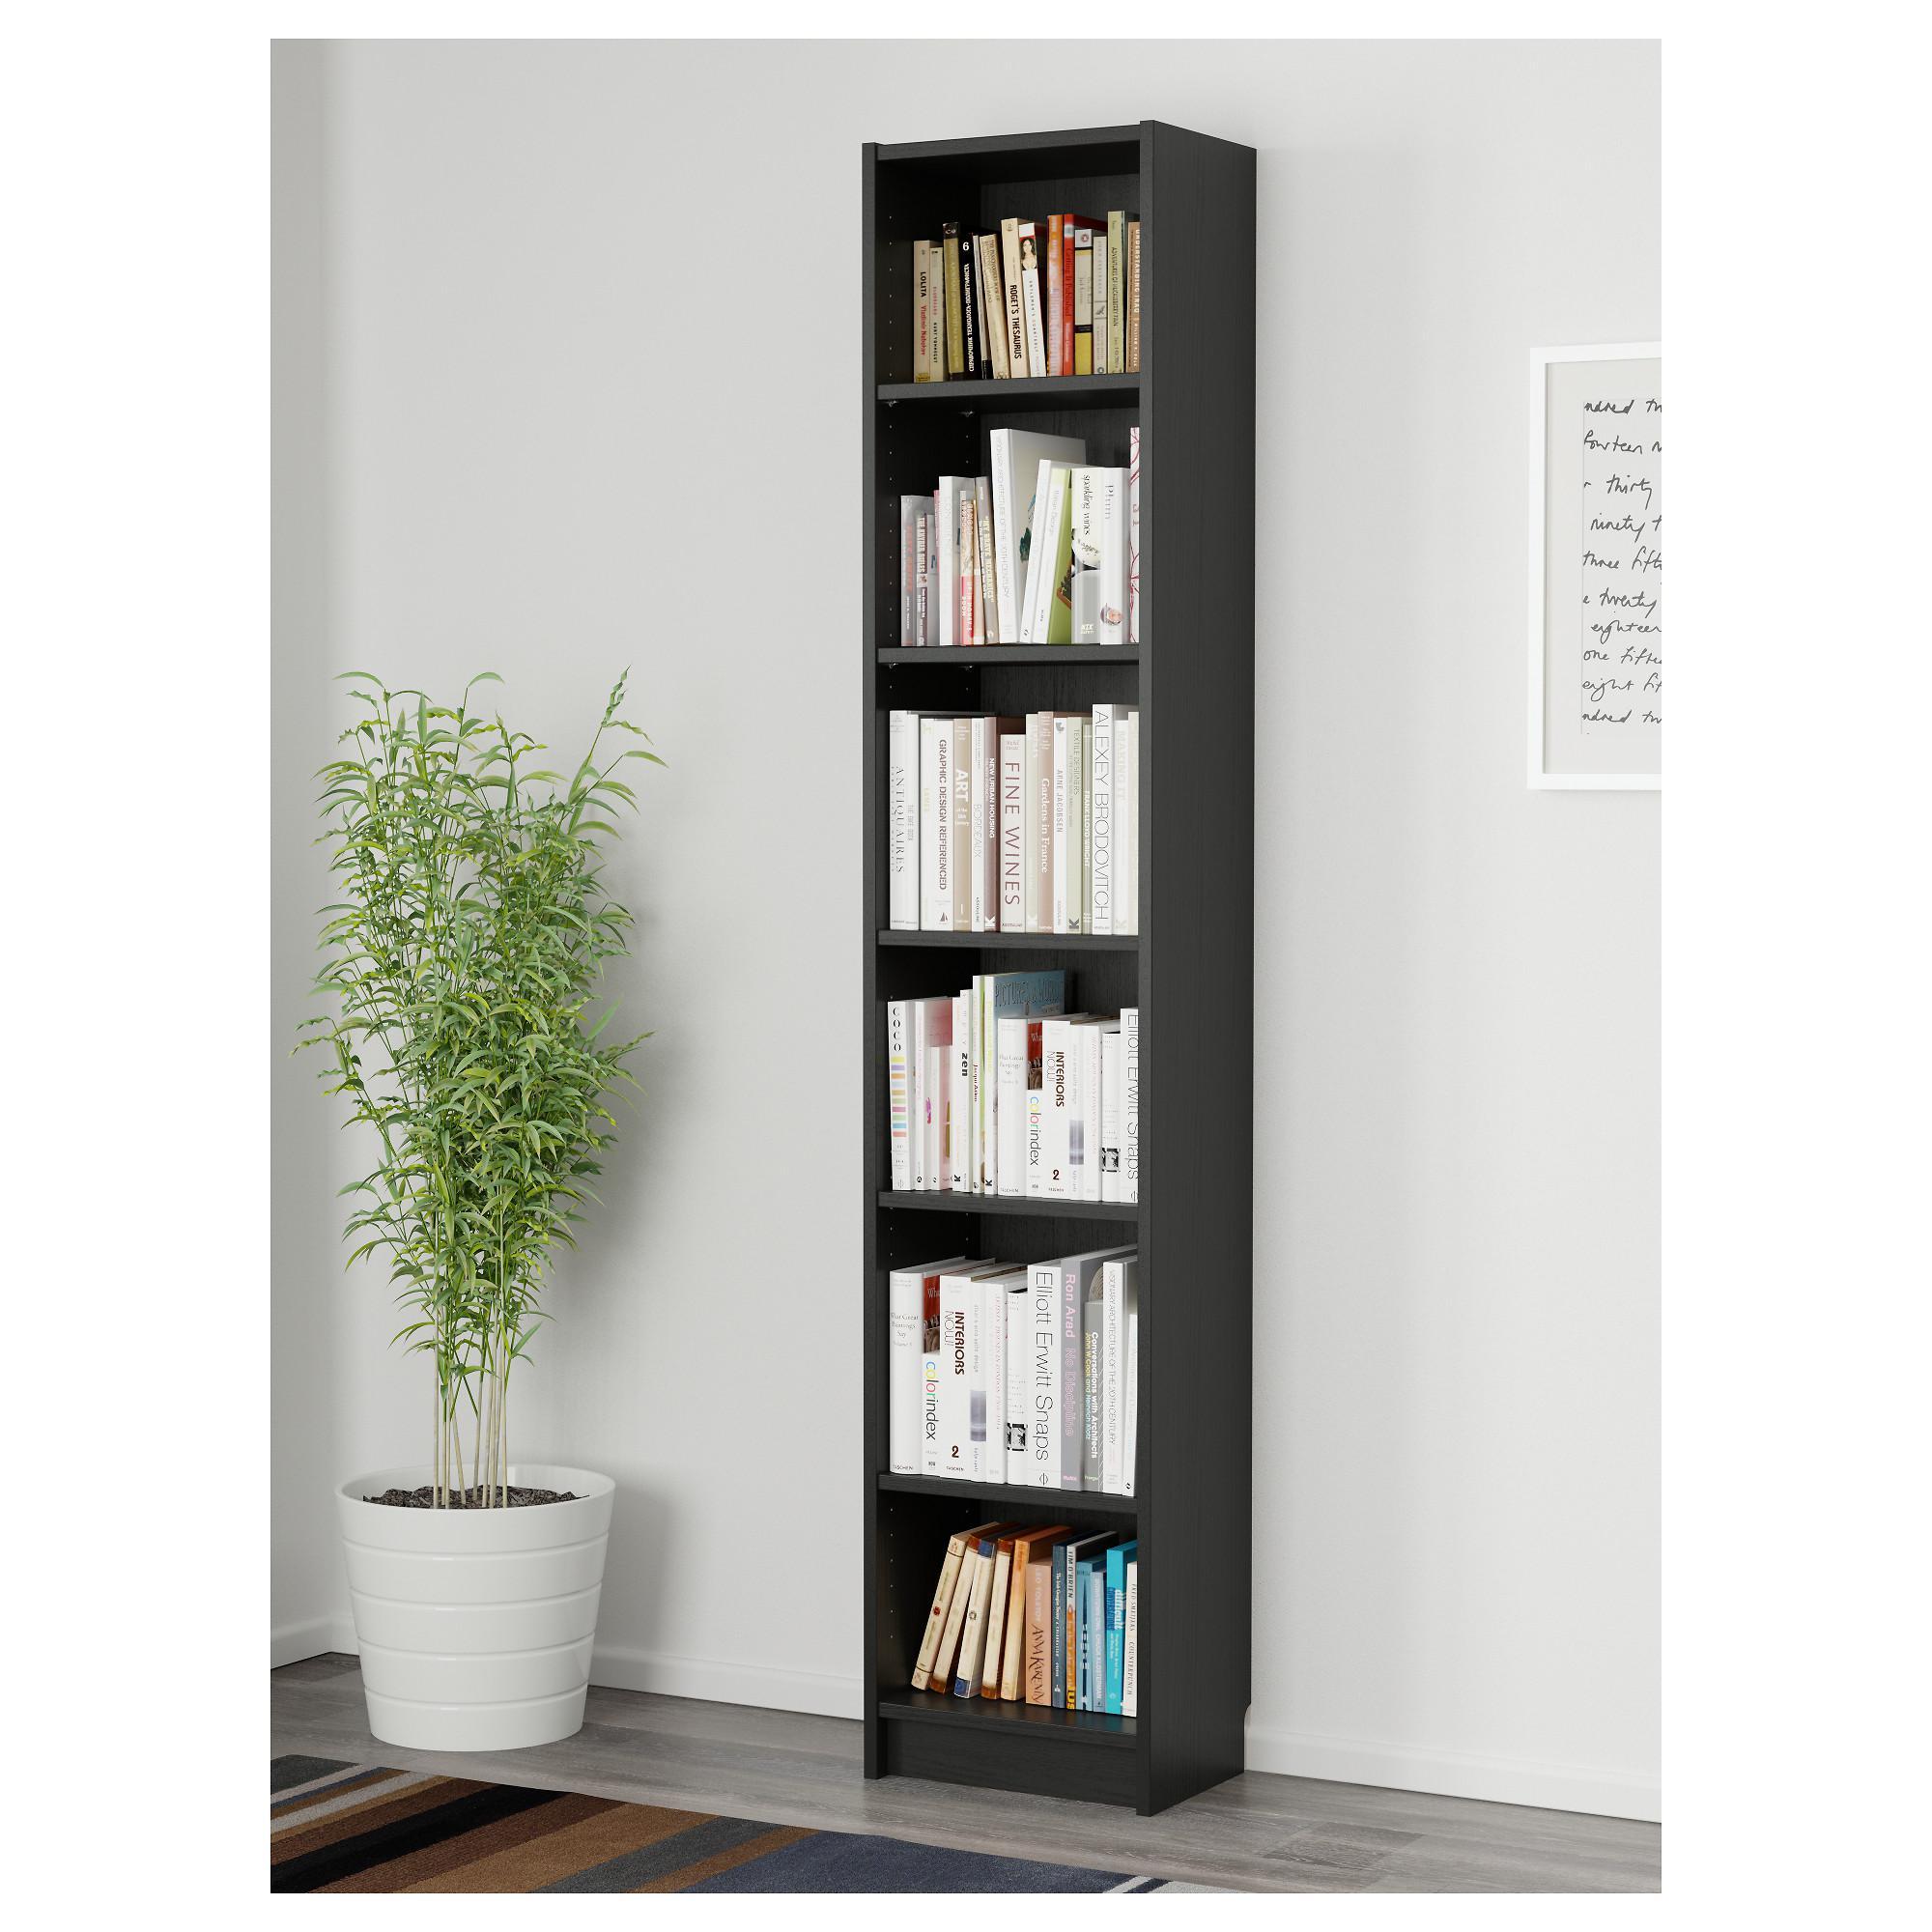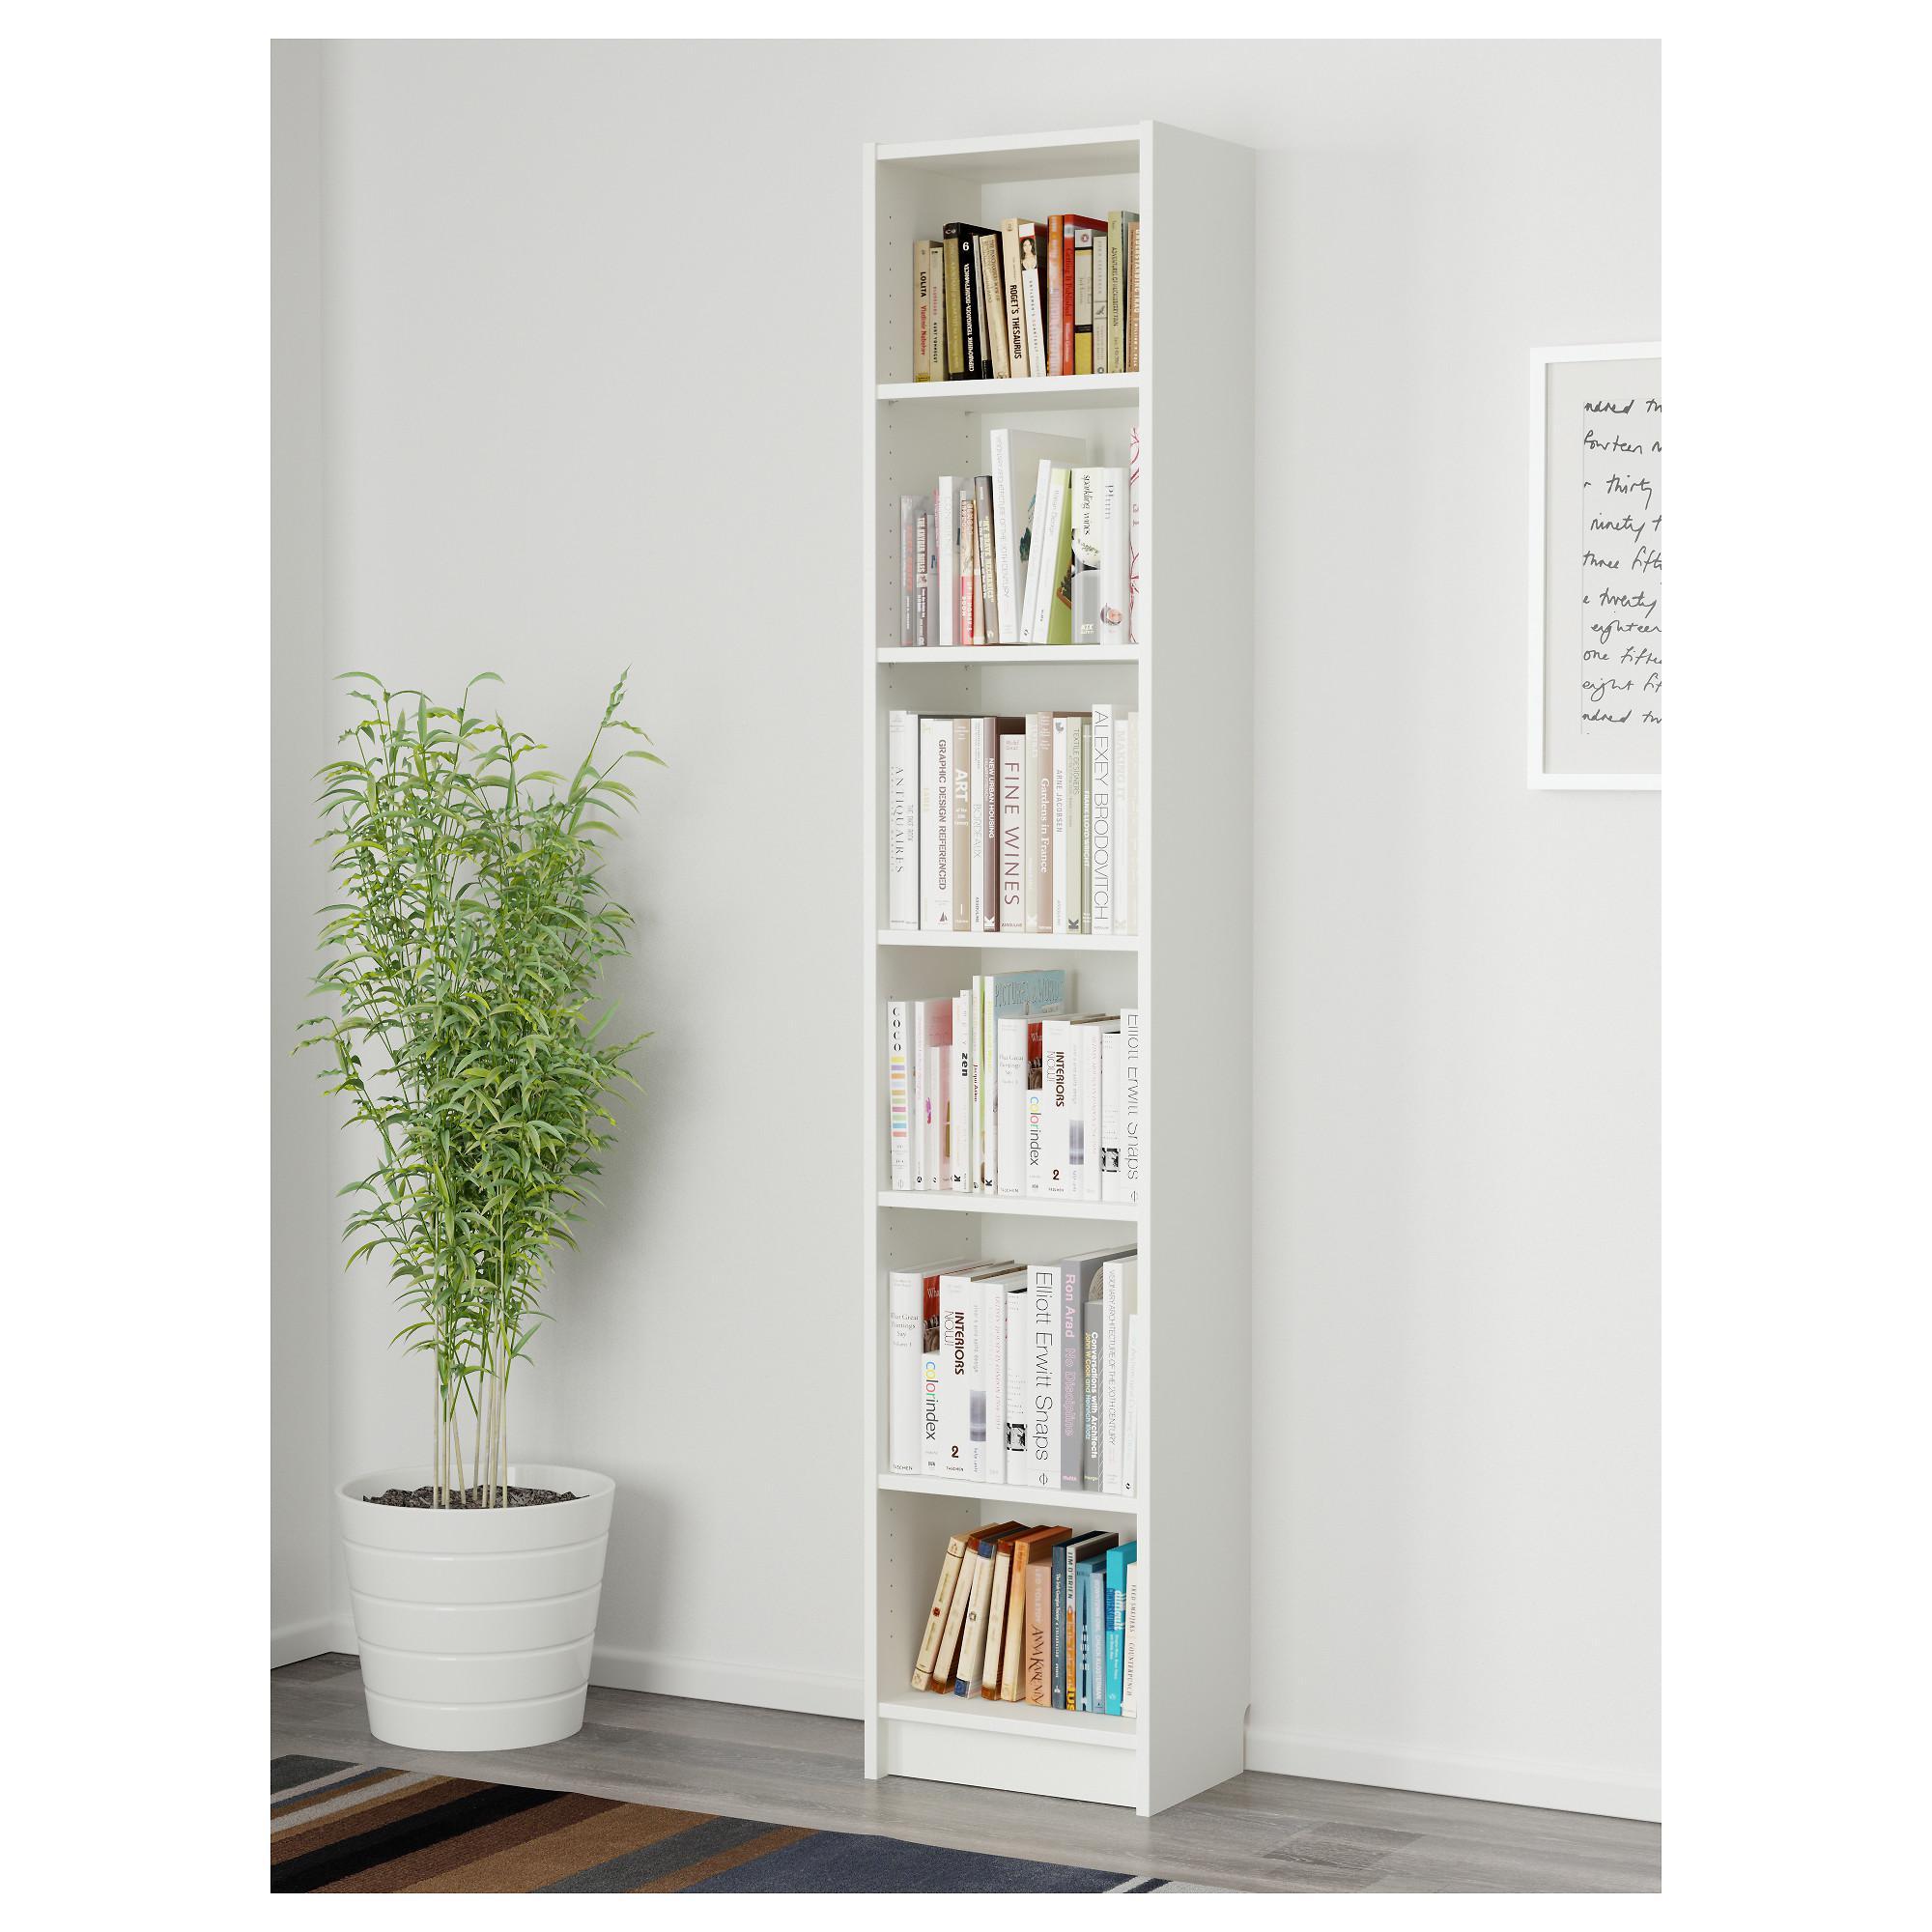The first image is the image on the left, the second image is the image on the right. Considering the images on both sides, is "The left image contains a bookshelf that is not white." valid? Answer yes or no. Yes. 